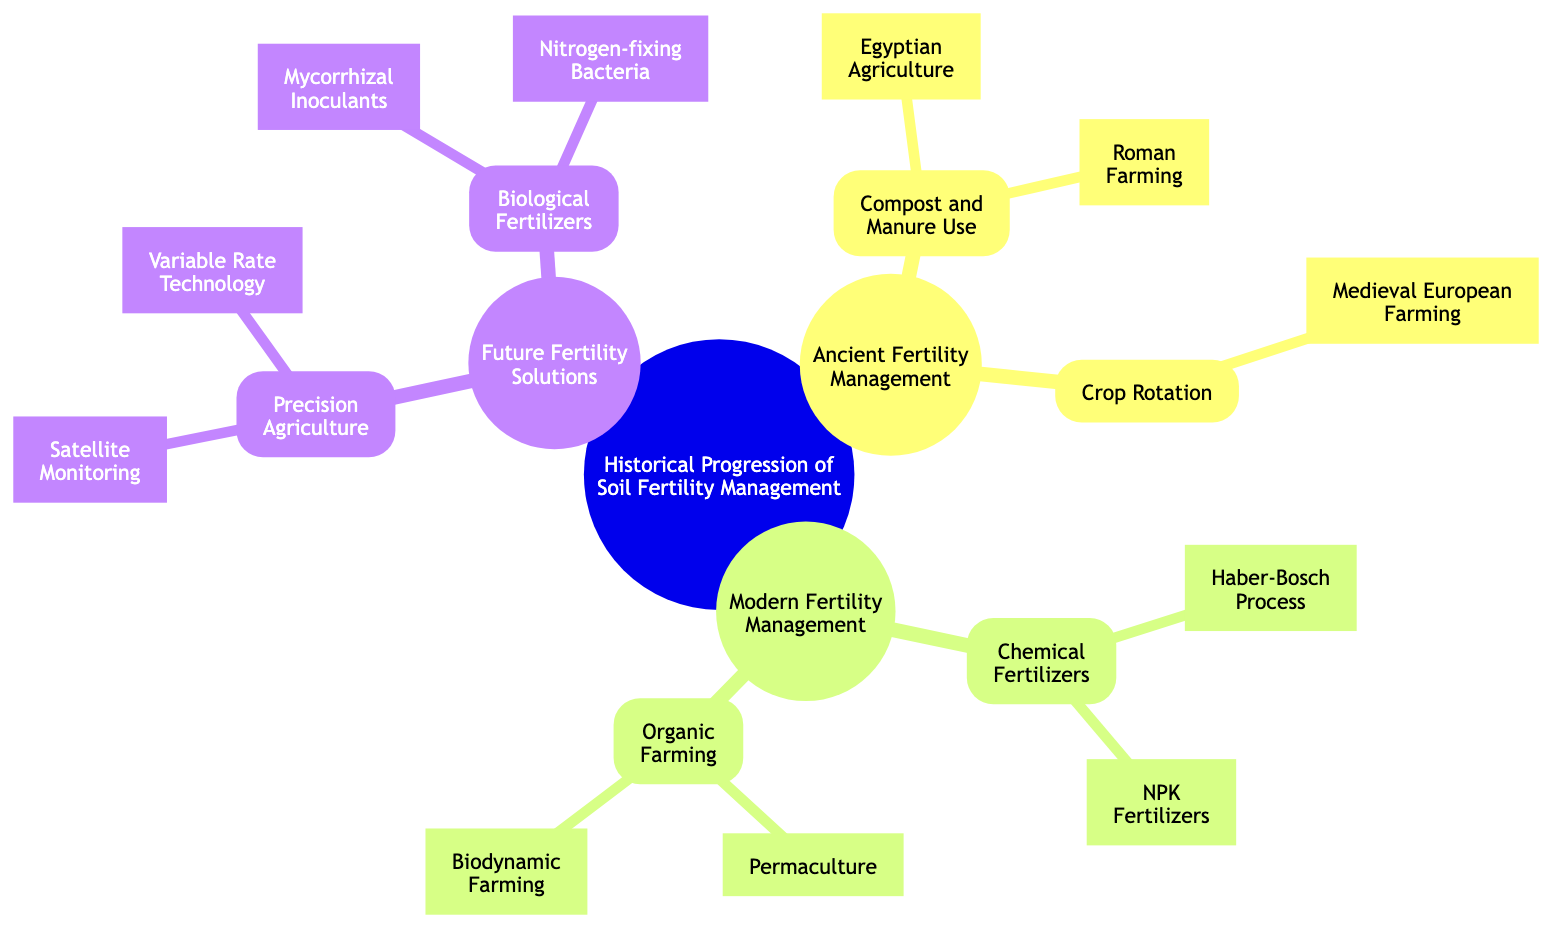What is the primary method under Ancient Fertility Management? The diagram indicates that the main category for Ancient Fertility Management includes 'Compost and Manure Use' and 'Crop Rotation'. Therefore, the primary methods are those two elements combined.
Answer: Compost and Manure Use, Crop Rotation How many methods are listed under Modern Fertility Management? Under Modern Fertility Management, there are two main techniques listed: 'Chemical Fertilizers' and 'Organic Farming'. Therefore, by counting these categories, the answer is two methods total.
Answer: 2 Which historical method focuses on the use of microorganisms? The sub-category 'Biological Fertilizers' in Future Fertility Solutions indicates that methods like 'Mycorrhizal Inoculants' and 'Nitrogen-fixing Bacteria' use microorganisms. Thus, the method emphasizing microorganisms is 'Biological Fertilizers'.
Answer: Biological Fertilizers What is the relationship between Crop Rotation and Medieval European Farming? Crop Rotation is the general method, and Medieval European Farming is a specific example that falls under that method. Thus, the relationship is that Medieval European Farming is a child node of Crop Rotation.
Answer: Specific example of Crop Rotation Which technique utilizes satellite data for soil analysis? The diagram indicates 'Satellite Monitoring' as a child of 'Precision Agriculture' and specifically mentions its use in soil health and crop requirement analysis. Therefore, it is the technique that utilizes satellite data for those purposes.
Answer: Satellite Monitoring How many different techniques are associated with Organic Farming? According to the diagram, there are two distinct techniques associated with Organic Farming: 'Permaculture' and 'Biodynamic Farming'. Therefore, by counting these children nodes, the answer is two techniques.
Answer: 2 Which process is used for ammonia production in fertilizers? The 'Haber-Bosch Process' under 'Chemical Fertilizers' is specifically identified in the diagram as a method for industrial nitrogen fixation and ammonia production. Thus, it is the relevant process.
Answer: Haber-Bosch Process Which future solution involves adjusting fertilizer rates based on soil variability? 'Variable Rate Technology', located under 'Precision Agriculture', is explicitly described as a method that adjusts fertilizer application rates based on soil variability. Hence, it is the targeted solution.
Answer: Variable Rate Technology What type of farming treats farms as unified organisms? 'Biodynamic Farming' is mentioned under 'Organic Farming' and is specifically noted to treat farms as unified organisms, distinguishing it within the category of organic practices. Thus, it is the answer to the query.
Answer: Biodynamic Farming 